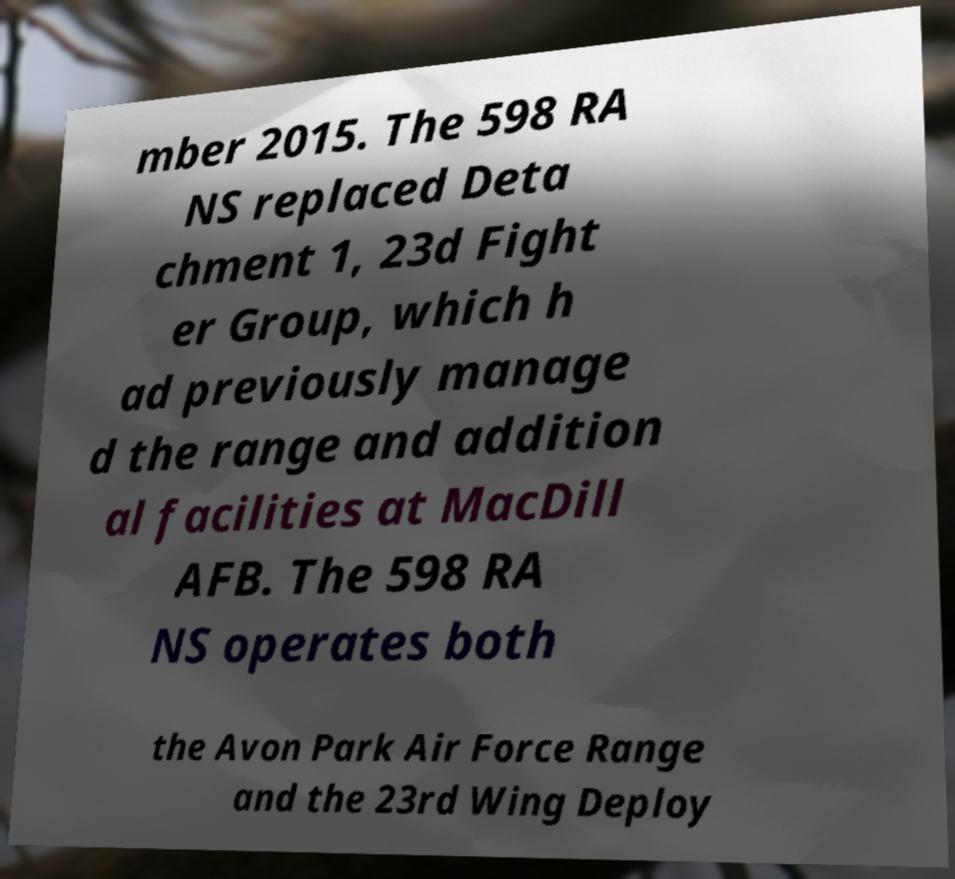There's text embedded in this image that I need extracted. Can you transcribe it verbatim? mber 2015. The 598 RA NS replaced Deta chment 1, 23d Fight er Group, which h ad previously manage d the range and addition al facilities at MacDill AFB. The 598 RA NS operates both the Avon Park Air Force Range and the 23rd Wing Deploy 